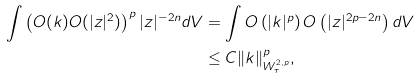<formula> <loc_0><loc_0><loc_500><loc_500>\int \left ( O ( k ) O ( | z | ^ { 2 } ) \right ) ^ { p } | z | ^ { - 2 n } d V & = \int O \left ( | k | ^ { p } \right ) O \left ( | z | ^ { 2 p - 2 n } \right ) d V \\ & \leq C \| k \| _ { W ^ { 2 , p } _ { \tau } } ^ { p } ,</formula> 